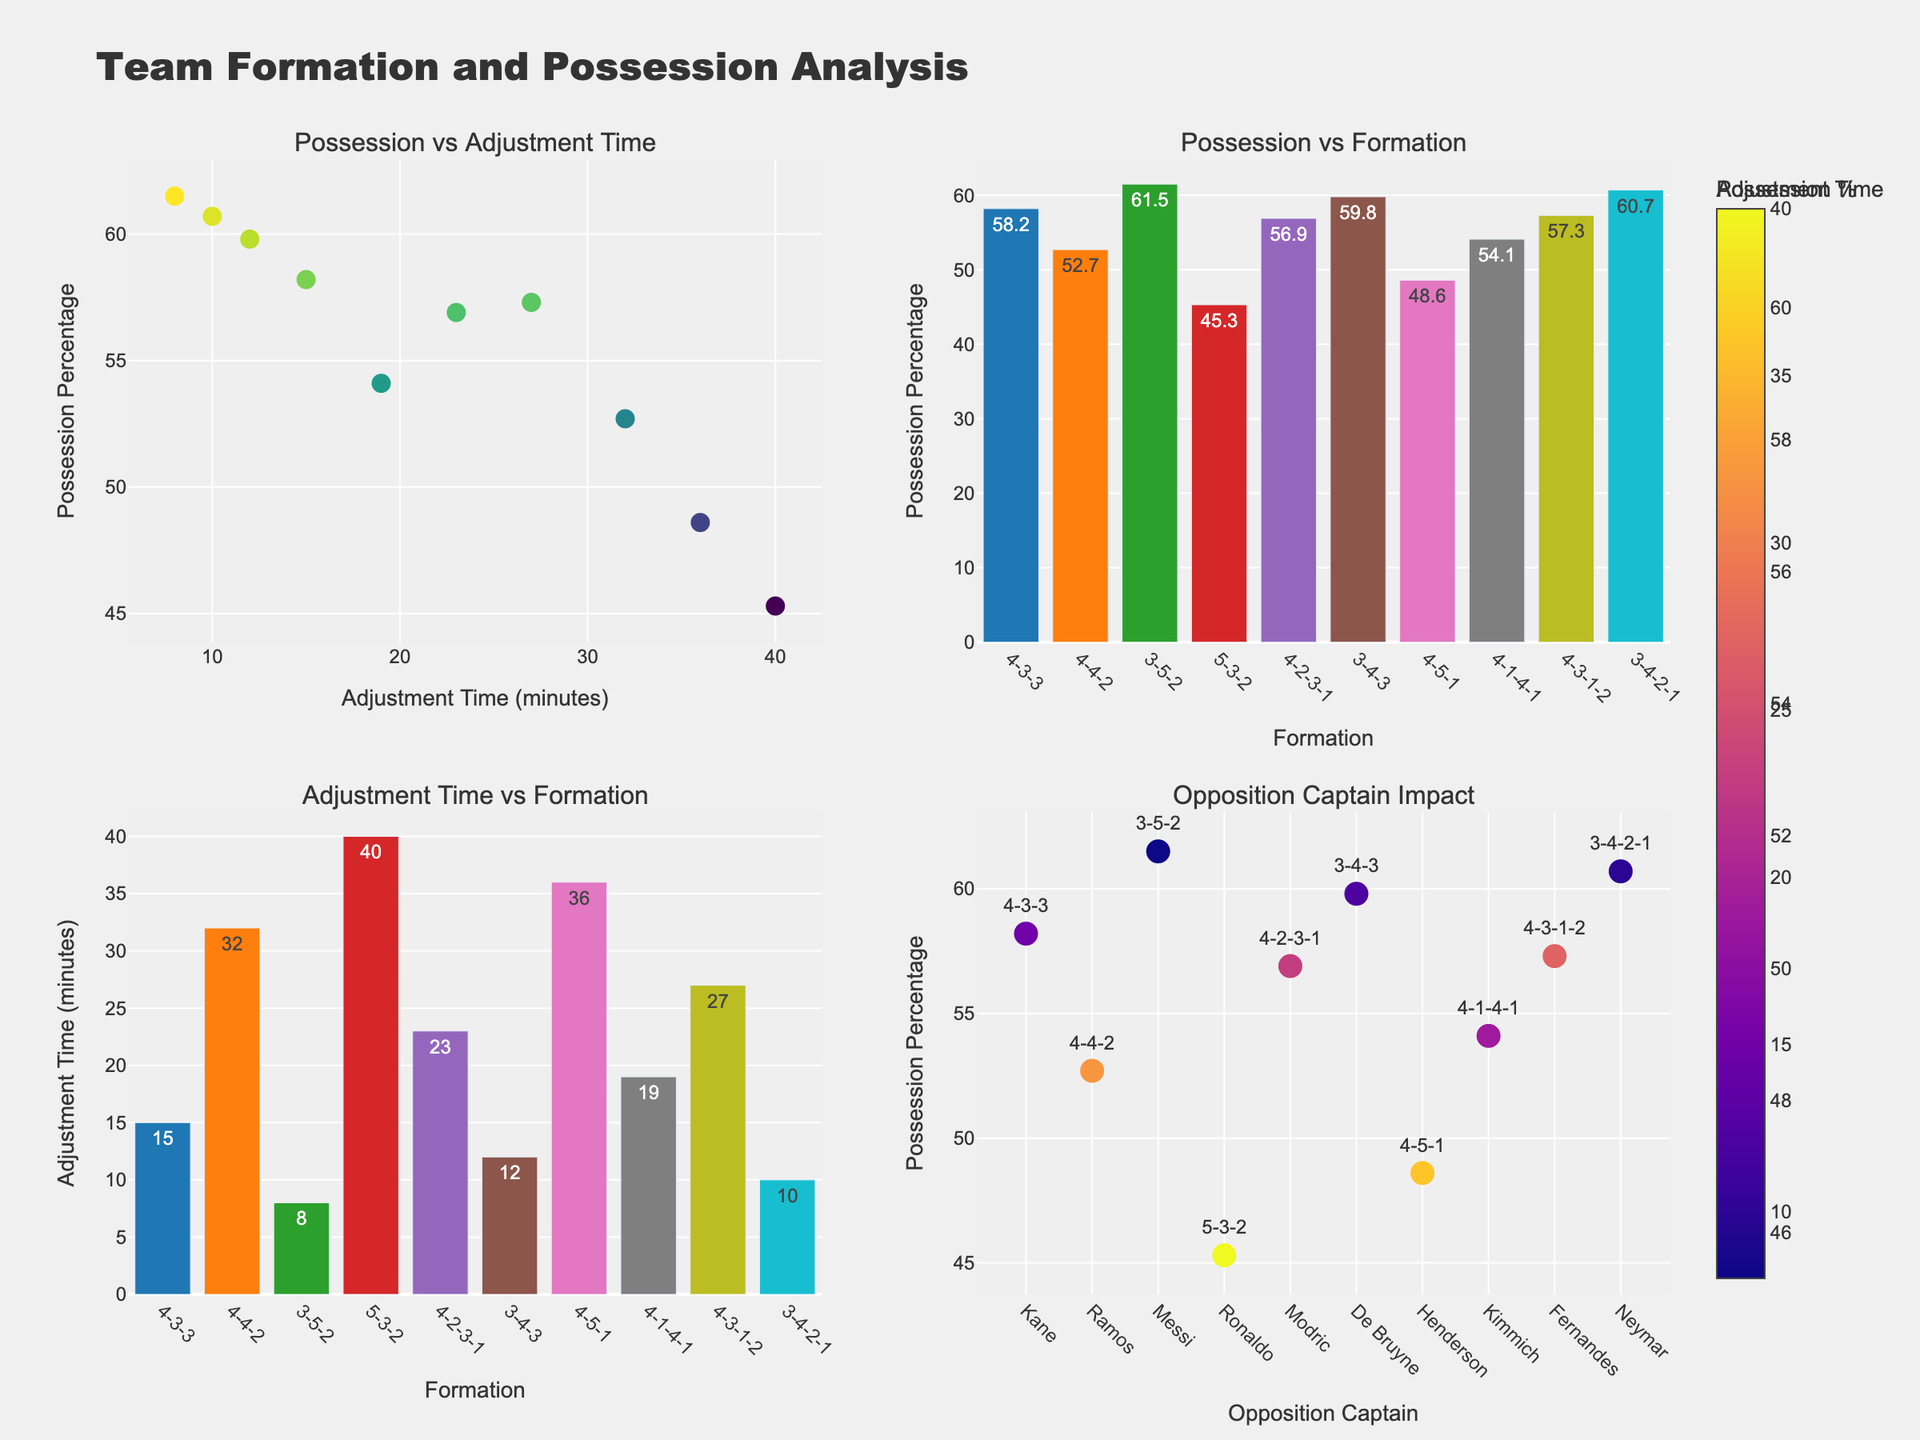What's the relationship between adjustment time and possession percentage? By observing the scatter plot "Possession vs Adjustment Time," you can see if there's a trend (positive, negative, or no correlation) between these two variables. Check if the points tend to increase, decrease, or have no apparent pattern.
Answer: Generally, no clear trend Which formation has the highest ball possession percentage? Refer to the bar chart titled "Possession vs Formation" and identify the bar with the highest value.
Answer: 3-5-2 Is there any formation with a possession percentage greater than 60%? Look at the scatter plot "Possession vs Adjustment Time" and note formations with possession percentages greater than 60%.
Answer: Yes, 3-5-2, 3-4-3, and 3-4-2-1 How does the adjustment time vary among different formations? Refer to the bar chart "Adjustment Time vs Formation" to compare the adjustment times for each formation.
Answer: Ranges from 8 to 40 minutes Does any one of Messi or Neymar's teams have a possession percentage of at least 60%? Check the 'Opposition Captain Impact' scatter plot for points where the captain is Messi or Neymar and verify their possession percentages.
Answer: Yes, both Messi and Neymar Which opposition captain corresponds to the highest adjustment time? Look at the "Opposition Captain Impact" scatter plot, identify the largest marker, and check the adjustment time.
Answer: Ronaldo What is the average ball possession percentage for formations with 4 defenders? Identify formations with 4 defenders (4-3-3, 4-4-2, 4-2-3-1, 4-5-1, 4-1-4-1, 4-3-1-2). Sum their possession percentages and divide by the number of formations.
Answer: (58.2 + 52.7 + 56.9 + 48.6 + 54.1 + 57.3) / 6 = 54.63 Which formation has the quickest adjustment time? Refer to the bar chart "Adjustment Time vs Formation" and find the formation with the least adjustment time.
Answer: 3-5-2 Is there any opposition captain whose teams always have a possession percentage below 50%? Check the "Opposition Captain Impact" scatter plot for markers below the 50% possession line and identify the corresponding captain.
Answer: No What color scale is used to represent the possession percentage in the scatter plot "Possession vs Adjustment Time"? Look for the color scale shown next to the scatter plot for "Possession vs Adjustment Time."
Answer: Viridis 